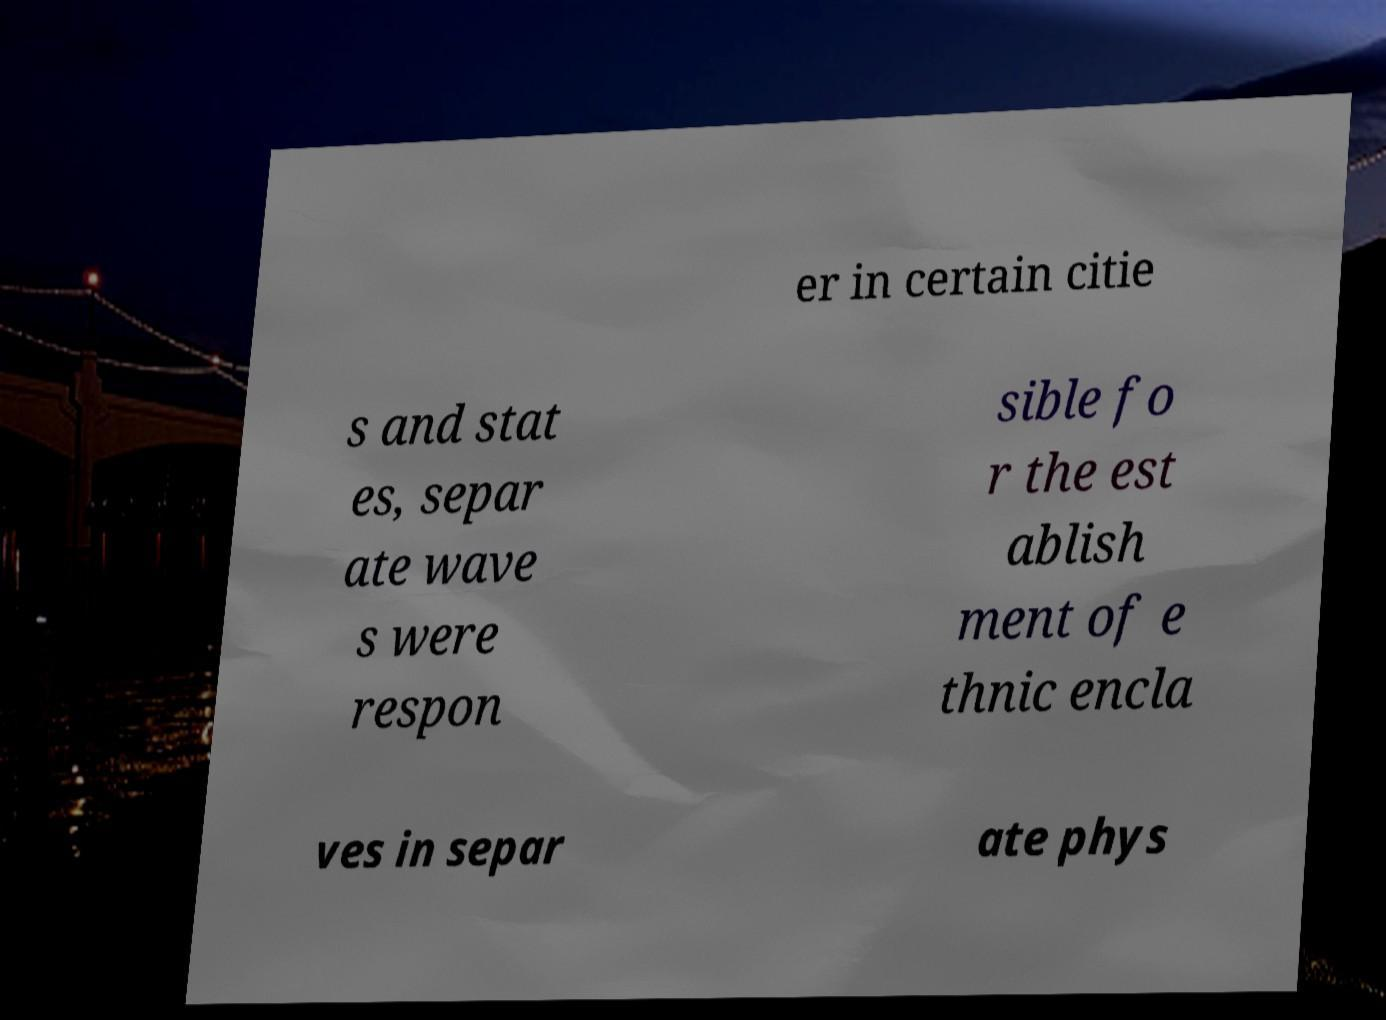Could you assist in decoding the text presented in this image and type it out clearly? er in certain citie s and stat es, separ ate wave s were respon sible fo r the est ablish ment of e thnic encla ves in separ ate phys 